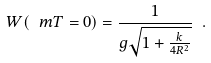<formula> <loc_0><loc_0><loc_500><loc_500>W ( \ m T = 0 ) = \frac { 1 } { g \sqrt { 1 + \frac { k } { 4 R ^ { 2 } } } } \ .</formula> 